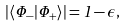<formula> <loc_0><loc_0><loc_500><loc_500>| \langle \Phi _ { - } | \Phi _ { + } \rangle | = 1 - \epsilon ,</formula> 